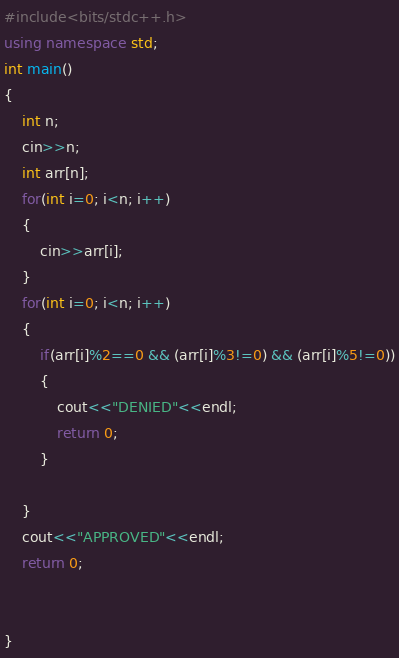<code> <loc_0><loc_0><loc_500><loc_500><_C++_>
#include<bits/stdc++.h>
using namespace std;
int main()
{
    int n;
    cin>>n;
    int arr[n];
    for(int i=0; i<n; i++)
    {
        cin>>arr[i];
    }
    for(int i=0; i<n; i++)
    {
        if(arr[i]%2==0 && (arr[i]%3!=0) && (arr[i]%5!=0))
        {
            cout<<"DENIED"<<endl;
            return 0;
        }

    }
    cout<<"APPROVED"<<endl;
    return 0;


}
</code> 